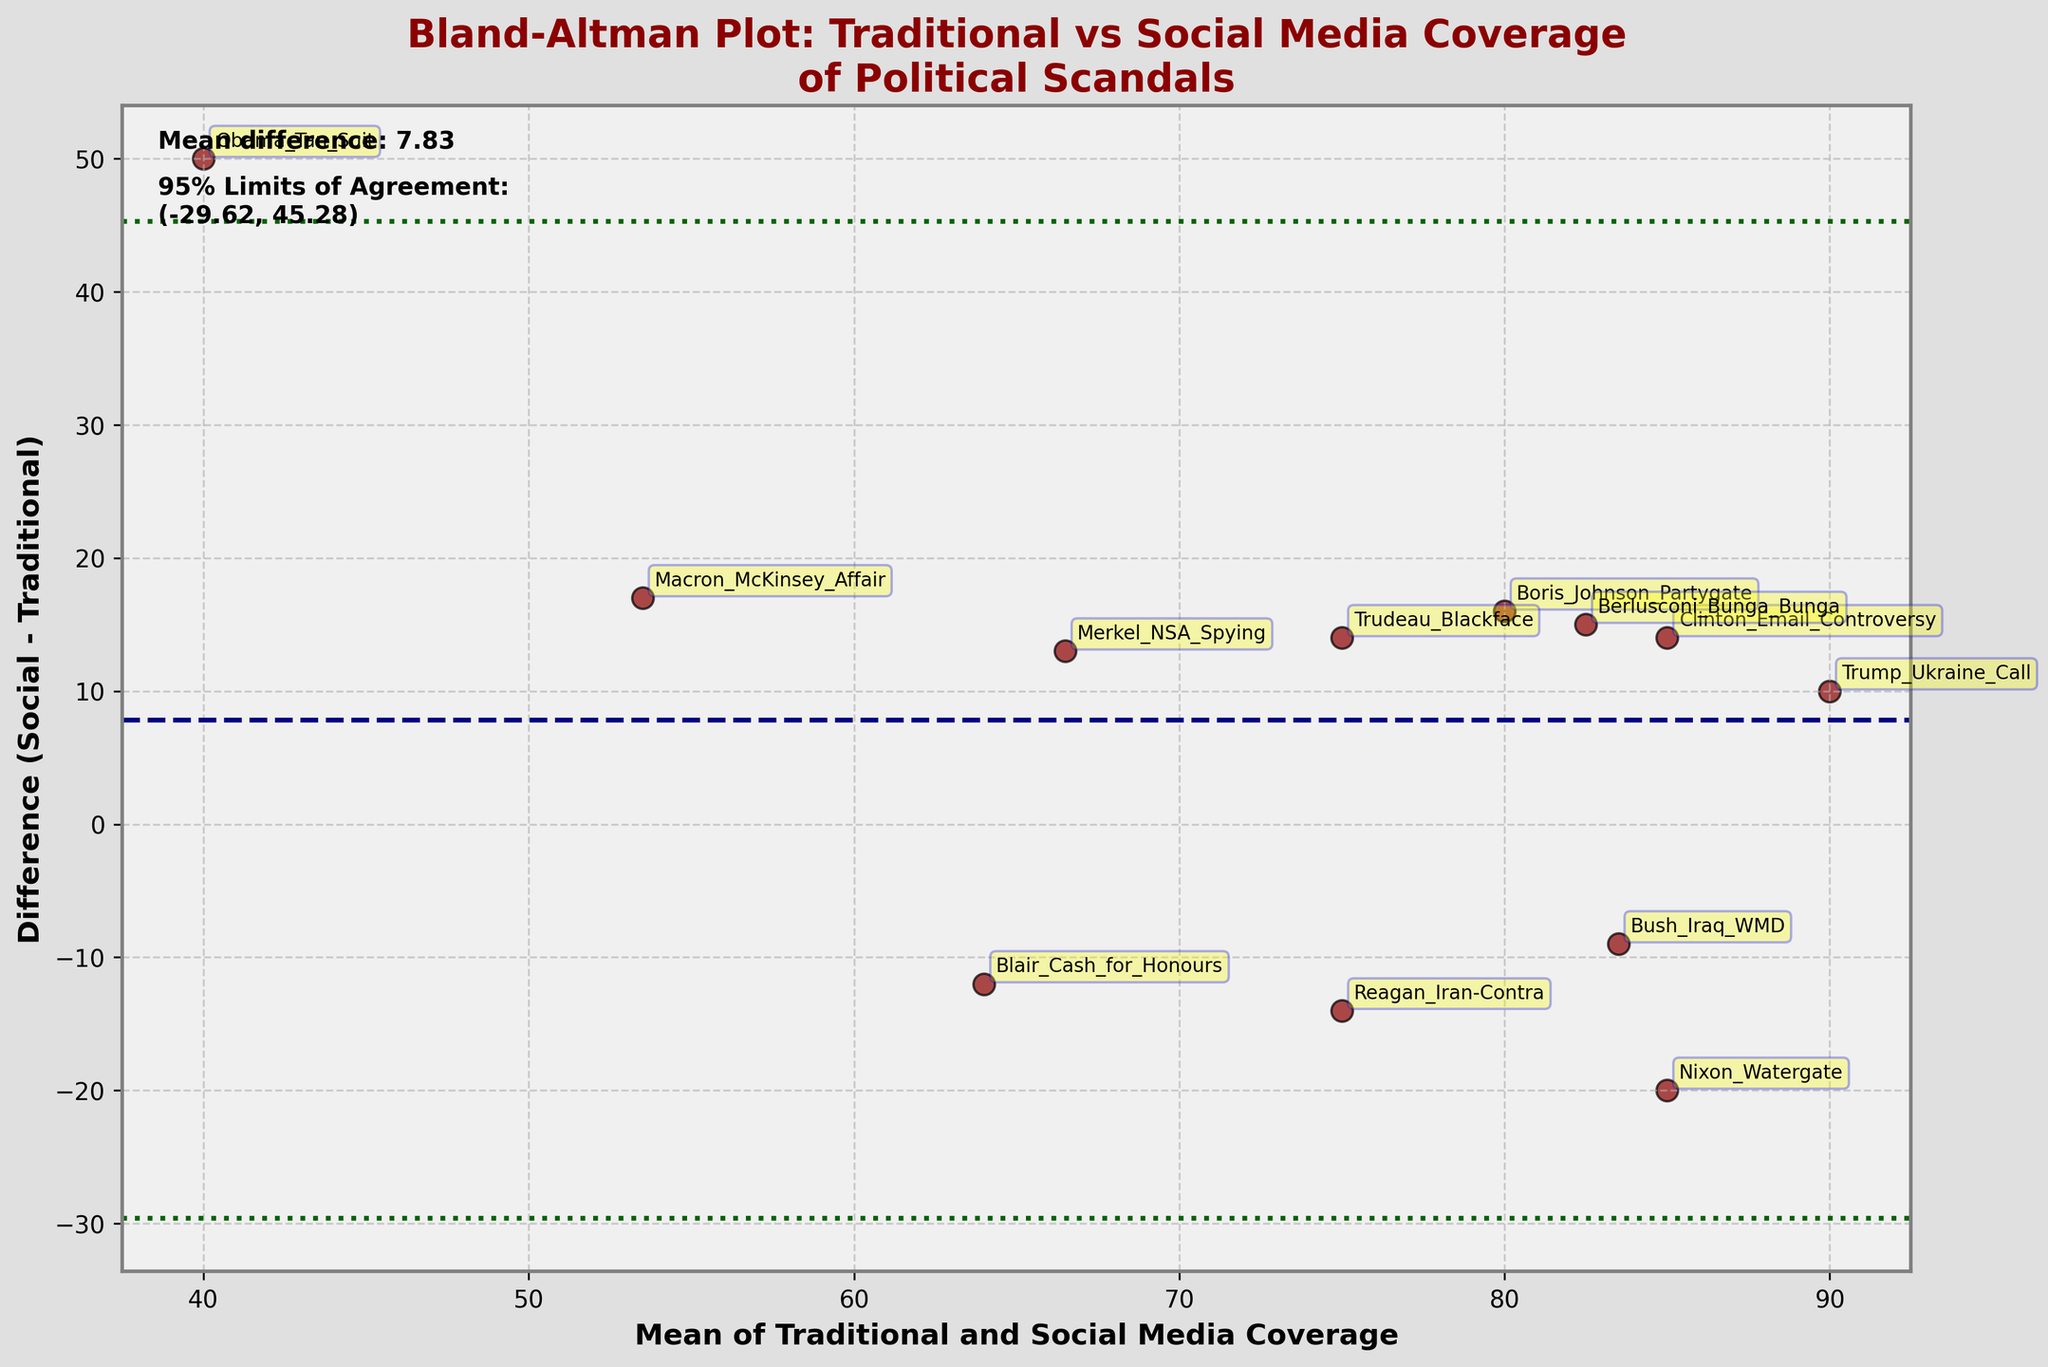How many data points are represented in the plot? Count the number of unique scandals annotated in the plot to determine the number of data points.
Answer: 12 What is the title of the plot? The title is displayed at the top of the plot indicating its purpose.
Answer: Bland-Altman Plot: Traditional vs Social Media Coverage of Political Scandals What is the mean difference shown in the plot? The mean difference is written on the plot and is the central dashed line.
Answer: 5.33 Which scandal shows the highest difference between social media and traditional media coverage? Identify the point with the largest vertical distance from the mean of traditional and social media coverage. Look for the maximum positive difference.
Answer: Obama Tan Suit Which scandal has the least average media coverage between traditional and social media? Identify the point that is positioned the furthest to the left on the horizontal axis (mean coverage).
Answer: Obama Tan Suit What are the 95% Limits of Agreement in the plot? The limits are displayed as horizontal dotted lines in green and corresponding text annotations indicating their values.
Answer: (-12.45, 23.12) Is the difference in coverage for the Obama Tan Suit scandal above or below the mean difference line? Observe the position of the point for Obama Tan Suit relative to the central dashed line.
Answer: Above What is the difference between social and traditional media coverage for the Trump Ukraine Call scandal? Locate the Trump Ukraine Call scandal point and measure its vertical distance from the zero on the y-axis.
Answer: 10 For which scandal was traditional media coverage higher than social media coverage? Check for points that fall below the zero line on the y-axis, indicating that traditional coverage was greater.
Answer: Nixon Watergate, Reagan Iran-Contra, Blair Cash for Honours Which scandal, other than Obama Tan Suit, differs most significantly from the mean difference? Identify points with values furthest from the mean difference line. Only consider those with a significant distance.
Answer: Nixon Watergate 